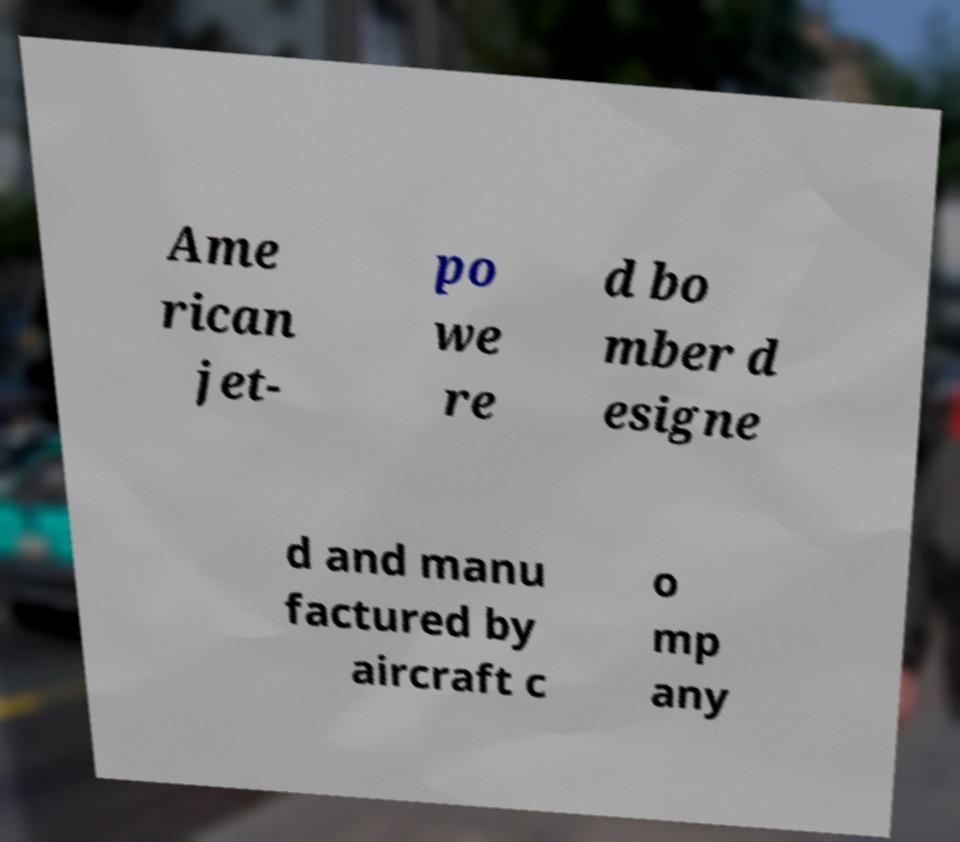For documentation purposes, I need the text within this image transcribed. Could you provide that? Ame rican jet- po we re d bo mber d esigne d and manu factured by aircraft c o mp any 